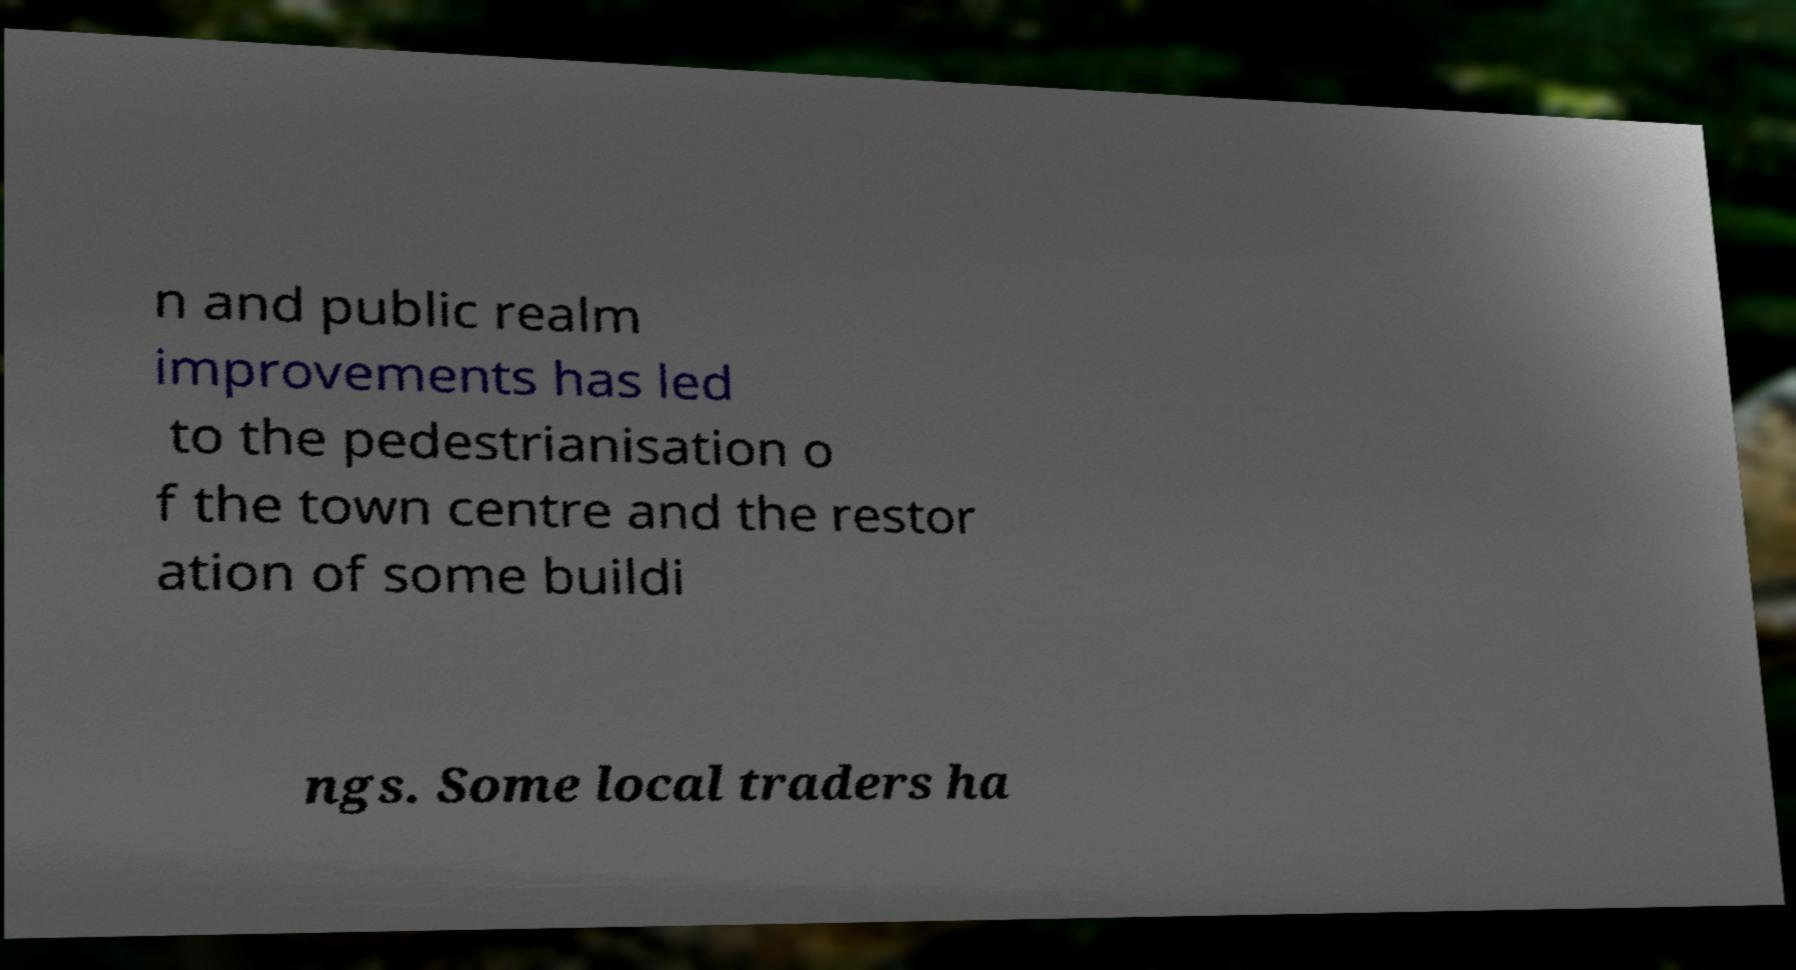Please read and relay the text visible in this image. What does it say? n and public realm improvements has led to the pedestrianisation o f the town centre and the restor ation of some buildi ngs. Some local traders ha 